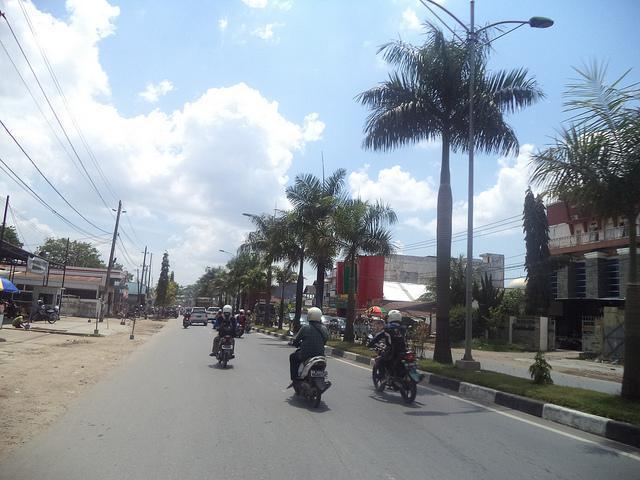How many layers does this cake have?
Give a very brief answer. 0. 